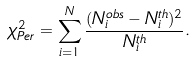Convert formula to latex. <formula><loc_0><loc_0><loc_500><loc_500>\chi _ { P e r } ^ { 2 } = \sum _ { i = 1 } ^ { N } \frac { ( N _ { i } ^ { o b s } - N _ { i } ^ { t h } ) ^ { 2 } } { N _ { i } ^ { t h } } .</formula> 